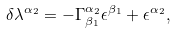<formula> <loc_0><loc_0><loc_500><loc_500>\delta \lambda ^ { \alpha _ { 2 } } = - \Gamma _ { \beta _ { 1 } } ^ { \alpha _ { 2 } } \epsilon ^ { \beta _ { 1 } } + \epsilon ^ { \alpha _ { 2 } } ,</formula> 